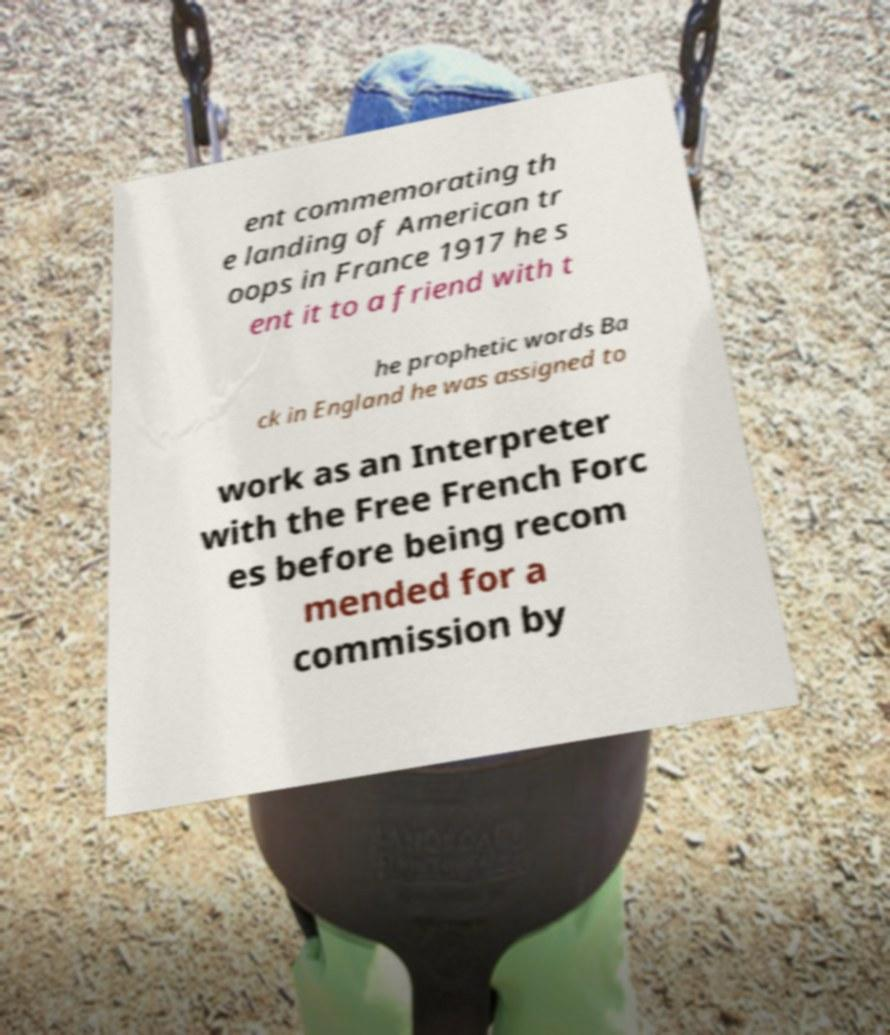Could you extract and type out the text from this image? ent commemorating th e landing of American tr oops in France 1917 he s ent it to a friend with t he prophetic words Ba ck in England he was assigned to work as an Interpreter with the Free French Forc es before being recom mended for a commission by 